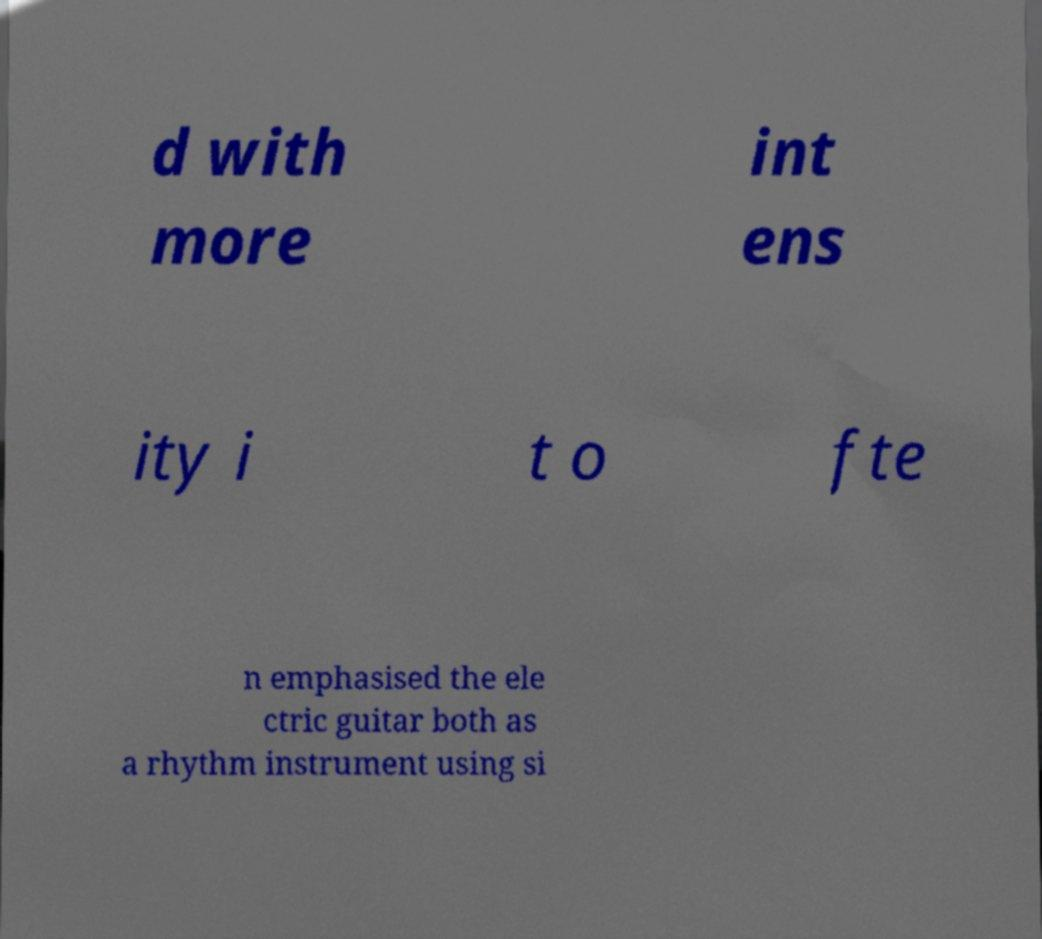I need the written content from this picture converted into text. Can you do that? d with more int ens ity i t o fte n emphasised the ele ctric guitar both as a rhythm instrument using si 